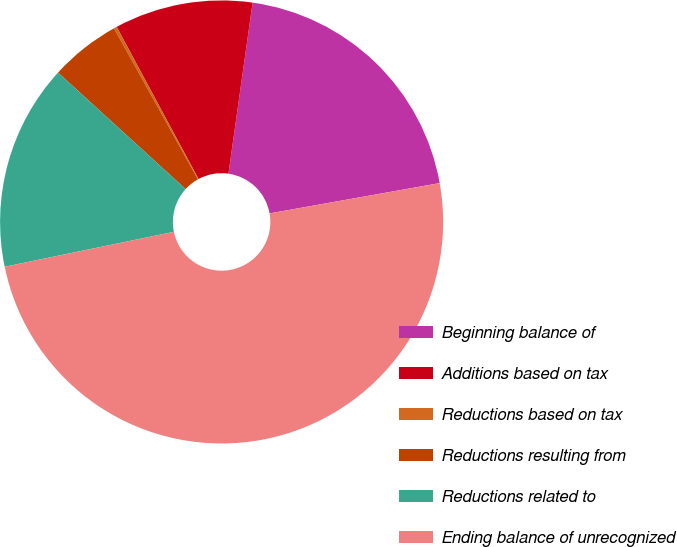<chart> <loc_0><loc_0><loc_500><loc_500><pie_chart><fcel>Beginning balance of<fcel>Additions based on tax<fcel>Reductions based on tax<fcel>Reductions resulting from<fcel>Reductions related to<fcel>Ending balance of unrecognized<nl><fcel>19.96%<fcel>10.09%<fcel>0.22%<fcel>5.15%<fcel>15.02%<fcel>49.57%<nl></chart> 